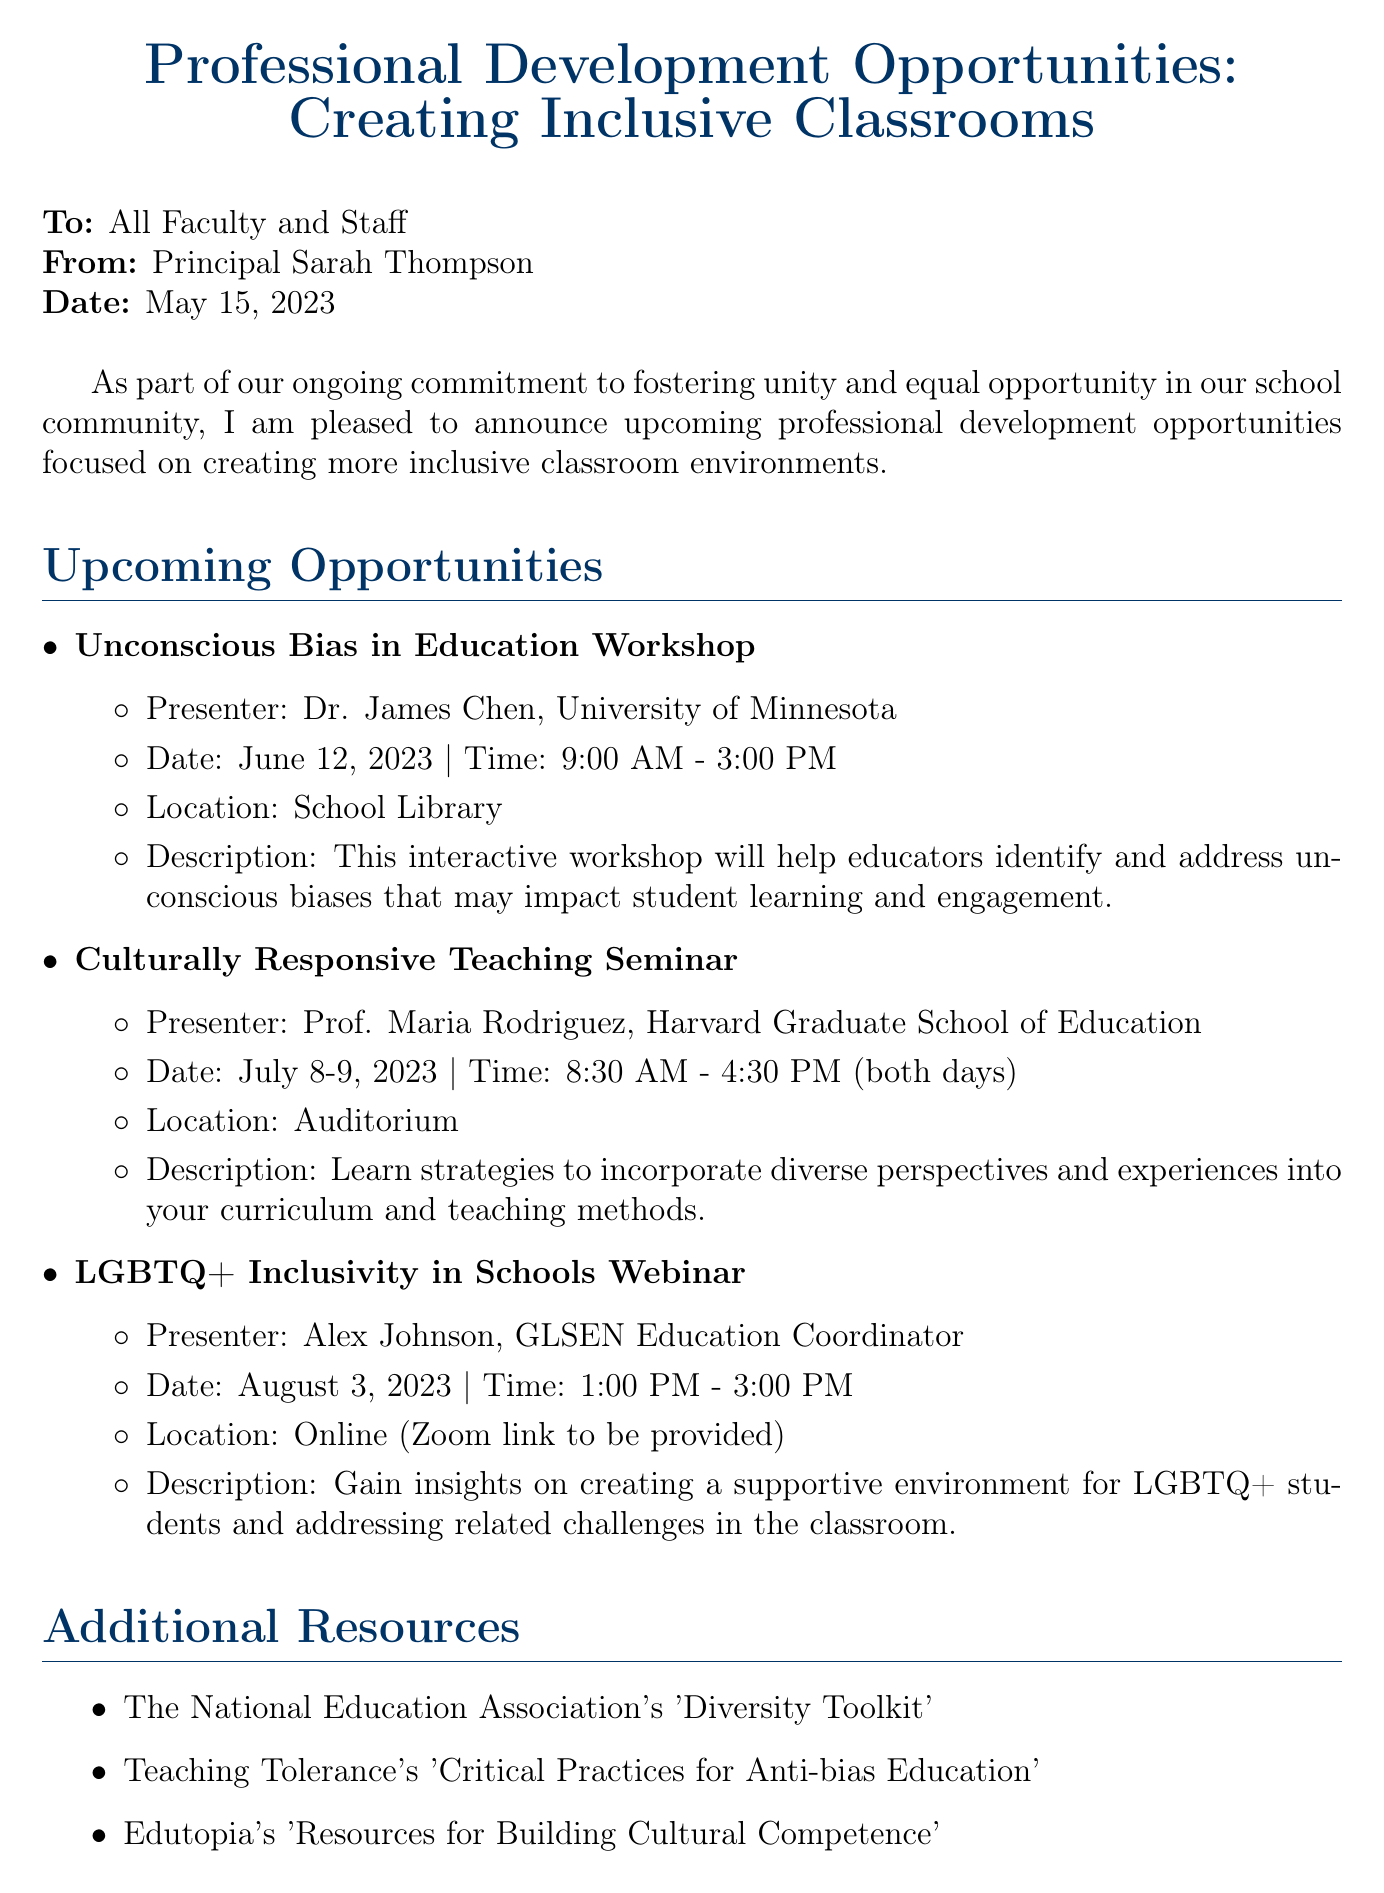What is the title of the memo? The title of the memo is stated at the beginning, emphasizing professional development opportunities in inclusive classrooms.
Answer: Professional Development Opportunities: Creating Inclusive Classrooms Who is the presenter of the Unconscious Bias in Education Workshop? The presenter is mentioned alongside the workshop title, indicating who will lead the session.
Answer: Dr. James Chen, University of Minnesota What is the registration deadline for these opportunities? The deadline is explicitly mentioned in the registration information section of the memo.
Answer: May 31, 2023 How many days does the Culturally Responsive Teaching Seminar span? The seminar's duration is specified in the description of the opportunity, indicating the number of days it covers.
Answer: Two days What is the location of the LGBTQ+ Inclusivity in Schools Webinar? The location is provided in the description of the webinar, highlighting that it is not in-person.
Answer: Online (Zoom link to be provided) Why is participation in these professional development opportunities emphasized? The closing statement stresses the importance of creating inclusive learning environments and supporting all students.
Answer: To promote unity and equal opportunity What are the funding details for the professional development sessions? The funding information is included in the registration details, clarifying cost coverage by the school district.
Answer: The school district will cover all associated costs Who should be contacted for registration? The registration process specifies the person to contact along with their email address.
Answer: Ms. Emily Parker (e.parker@northernhigh.edu) 